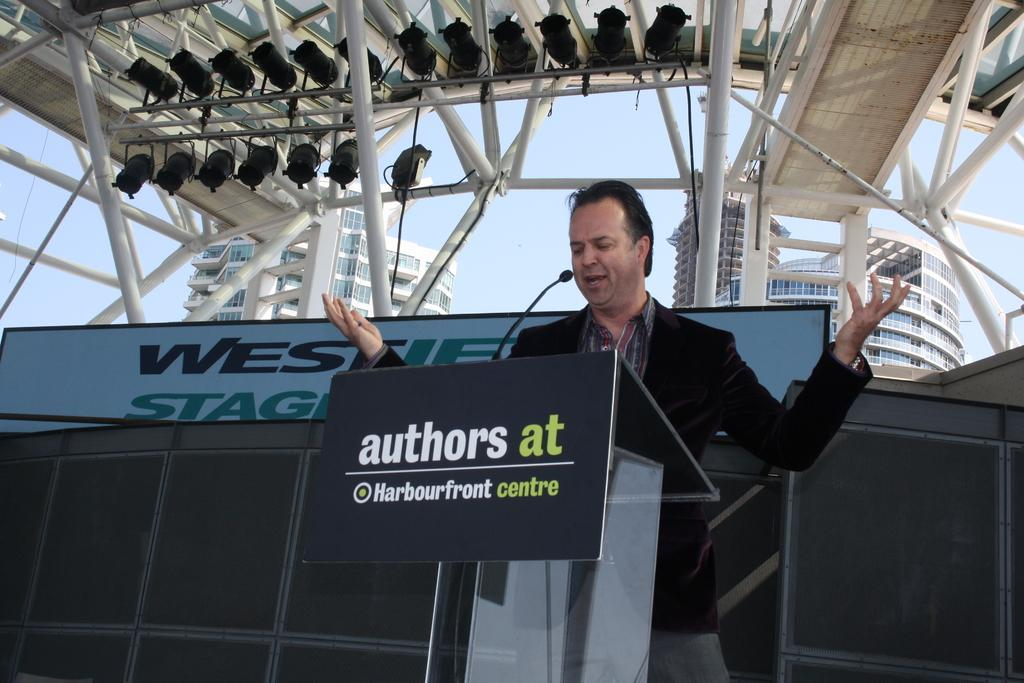What is the man in the image doing? The man is standing and talking. Where is the man located in the image? The man is in front of a microphone on a podium. What can be seen in the background of the image? There are rods, a hoarding, buildings, and the sky visible in the background of the image. What type of butter is being used by the man in the image? There is no butter present in the image; the man is standing and talking in front of a microphone on a podium. What kind of drug is being administered to the cats in the image? There are no cats present in the image, and therefore no drug administration can be observed. 